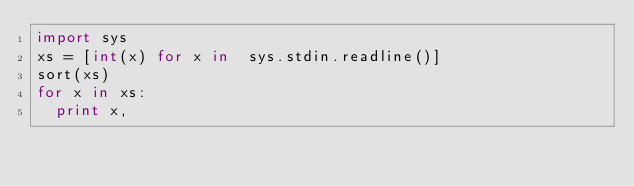Convert code to text. <code><loc_0><loc_0><loc_500><loc_500><_Python_>import sys
xs = [int(x) for x in  sys.stdin.readline()]
sort(xs)
for x in xs:
  print x,</code> 